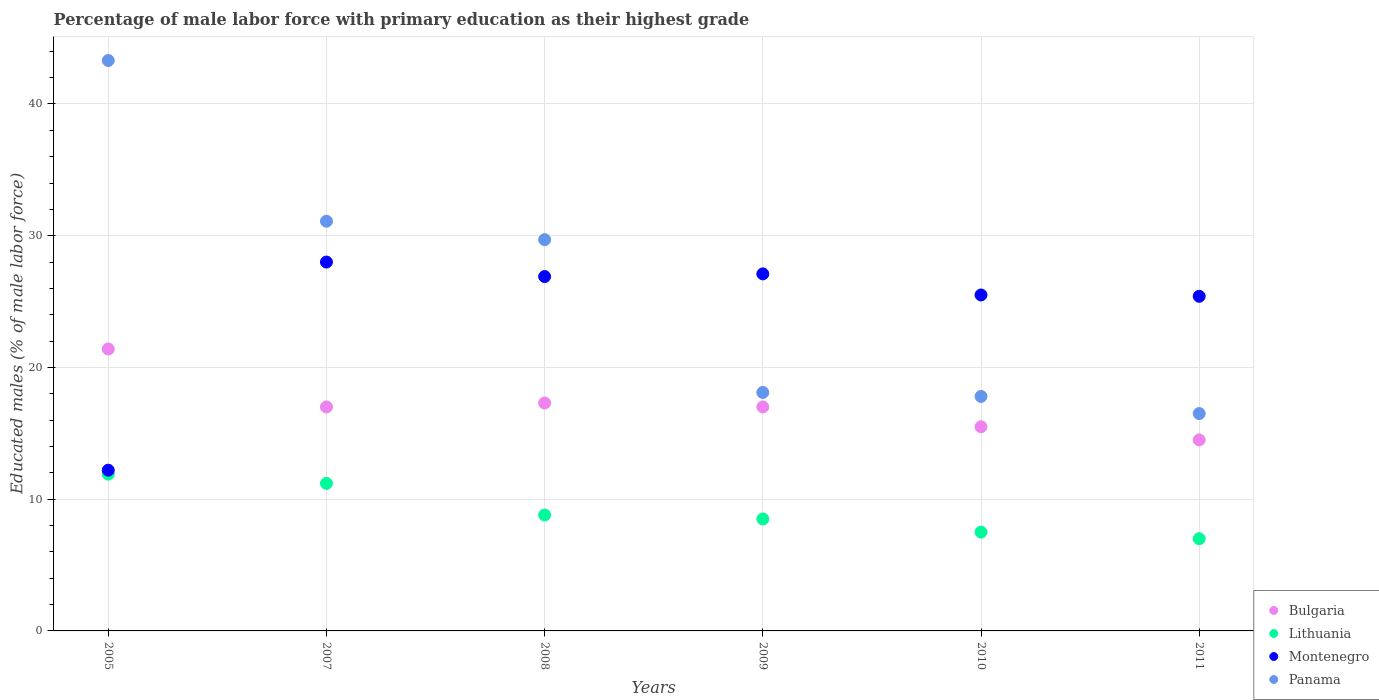Is the number of dotlines equal to the number of legend labels?
Your answer should be very brief. Yes. What is the percentage of male labor force with primary education in Montenegro in 2005?
Make the answer very short. 12.2. Across all years, what is the maximum percentage of male labor force with primary education in Lithuania?
Provide a succinct answer. 11.9. Across all years, what is the minimum percentage of male labor force with primary education in Lithuania?
Offer a terse response. 7. In which year was the percentage of male labor force with primary education in Panama maximum?
Offer a very short reply. 2005. What is the total percentage of male labor force with primary education in Bulgaria in the graph?
Keep it short and to the point. 102.7. What is the difference between the percentage of male labor force with primary education in Bulgaria in 2007 and that in 2010?
Keep it short and to the point. 1.5. What is the difference between the percentage of male labor force with primary education in Montenegro in 2005 and the percentage of male labor force with primary education in Lithuania in 2010?
Your answer should be compact. 4.7. What is the average percentage of male labor force with primary education in Bulgaria per year?
Make the answer very short. 17.12. In the year 2009, what is the difference between the percentage of male labor force with primary education in Bulgaria and percentage of male labor force with primary education in Panama?
Ensure brevity in your answer.  -1.1. What is the ratio of the percentage of male labor force with primary education in Montenegro in 2005 to that in 2011?
Provide a short and direct response. 0.48. Is the difference between the percentage of male labor force with primary education in Bulgaria in 2005 and 2008 greater than the difference between the percentage of male labor force with primary education in Panama in 2005 and 2008?
Give a very brief answer. No. What is the difference between the highest and the second highest percentage of male labor force with primary education in Panama?
Provide a short and direct response. 12.2. What is the difference between the highest and the lowest percentage of male labor force with primary education in Bulgaria?
Your response must be concise. 6.9. Is it the case that in every year, the sum of the percentage of male labor force with primary education in Montenegro and percentage of male labor force with primary education in Panama  is greater than the sum of percentage of male labor force with primary education in Bulgaria and percentage of male labor force with primary education in Lithuania?
Offer a very short reply. No. Does the percentage of male labor force with primary education in Panama monotonically increase over the years?
Your answer should be very brief. No. How many dotlines are there?
Offer a terse response. 4. How many years are there in the graph?
Your answer should be compact. 6. Are the values on the major ticks of Y-axis written in scientific E-notation?
Offer a terse response. No. Does the graph contain any zero values?
Provide a short and direct response. No. Where does the legend appear in the graph?
Your answer should be compact. Bottom right. How are the legend labels stacked?
Offer a terse response. Vertical. What is the title of the graph?
Your response must be concise. Percentage of male labor force with primary education as their highest grade. Does "Sri Lanka" appear as one of the legend labels in the graph?
Give a very brief answer. No. What is the label or title of the X-axis?
Offer a very short reply. Years. What is the label or title of the Y-axis?
Provide a short and direct response. Educated males (% of male labor force). What is the Educated males (% of male labor force) of Bulgaria in 2005?
Ensure brevity in your answer.  21.4. What is the Educated males (% of male labor force) in Lithuania in 2005?
Make the answer very short. 11.9. What is the Educated males (% of male labor force) of Montenegro in 2005?
Provide a succinct answer. 12.2. What is the Educated males (% of male labor force) in Panama in 2005?
Keep it short and to the point. 43.3. What is the Educated males (% of male labor force) in Lithuania in 2007?
Ensure brevity in your answer.  11.2. What is the Educated males (% of male labor force) of Montenegro in 2007?
Your response must be concise. 28. What is the Educated males (% of male labor force) in Panama in 2007?
Provide a short and direct response. 31.1. What is the Educated males (% of male labor force) of Bulgaria in 2008?
Ensure brevity in your answer.  17.3. What is the Educated males (% of male labor force) in Lithuania in 2008?
Provide a succinct answer. 8.8. What is the Educated males (% of male labor force) of Montenegro in 2008?
Your answer should be compact. 26.9. What is the Educated males (% of male labor force) of Panama in 2008?
Provide a succinct answer. 29.7. What is the Educated males (% of male labor force) in Lithuania in 2009?
Make the answer very short. 8.5. What is the Educated males (% of male labor force) in Montenegro in 2009?
Give a very brief answer. 27.1. What is the Educated males (% of male labor force) in Panama in 2009?
Ensure brevity in your answer.  18.1. What is the Educated males (% of male labor force) of Lithuania in 2010?
Offer a terse response. 7.5. What is the Educated males (% of male labor force) in Montenegro in 2010?
Ensure brevity in your answer.  25.5. What is the Educated males (% of male labor force) in Panama in 2010?
Your answer should be very brief. 17.8. What is the Educated males (% of male labor force) in Montenegro in 2011?
Provide a succinct answer. 25.4. Across all years, what is the maximum Educated males (% of male labor force) in Bulgaria?
Your answer should be compact. 21.4. Across all years, what is the maximum Educated males (% of male labor force) in Lithuania?
Your answer should be compact. 11.9. Across all years, what is the maximum Educated males (% of male labor force) of Panama?
Give a very brief answer. 43.3. Across all years, what is the minimum Educated males (% of male labor force) of Bulgaria?
Your answer should be compact. 14.5. Across all years, what is the minimum Educated males (% of male labor force) in Lithuania?
Offer a very short reply. 7. Across all years, what is the minimum Educated males (% of male labor force) of Montenegro?
Ensure brevity in your answer.  12.2. Across all years, what is the minimum Educated males (% of male labor force) of Panama?
Ensure brevity in your answer.  16.5. What is the total Educated males (% of male labor force) of Bulgaria in the graph?
Offer a very short reply. 102.7. What is the total Educated males (% of male labor force) of Lithuania in the graph?
Ensure brevity in your answer.  54.9. What is the total Educated males (% of male labor force) of Montenegro in the graph?
Your answer should be compact. 145.1. What is the total Educated males (% of male labor force) of Panama in the graph?
Provide a short and direct response. 156.5. What is the difference between the Educated males (% of male labor force) in Lithuania in 2005 and that in 2007?
Your answer should be compact. 0.7. What is the difference between the Educated males (% of male labor force) in Montenegro in 2005 and that in 2007?
Your answer should be compact. -15.8. What is the difference between the Educated males (% of male labor force) in Bulgaria in 2005 and that in 2008?
Keep it short and to the point. 4.1. What is the difference between the Educated males (% of male labor force) of Lithuania in 2005 and that in 2008?
Keep it short and to the point. 3.1. What is the difference between the Educated males (% of male labor force) in Montenegro in 2005 and that in 2008?
Make the answer very short. -14.7. What is the difference between the Educated males (% of male labor force) of Montenegro in 2005 and that in 2009?
Your answer should be very brief. -14.9. What is the difference between the Educated males (% of male labor force) of Panama in 2005 and that in 2009?
Offer a terse response. 25.2. What is the difference between the Educated males (% of male labor force) of Bulgaria in 2005 and that in 2010?
Provide a succinct answer. 5.9. What is the difference between the Educated males (% of male labor force) of Lithuania in 2005 and that in 2010?
Make the answer very short. 4.4. What is the difference between the Educated males (% of male labor force) in Panama in 2005 and that in 2010?
Ensure brevity in your answer.  25.5. What is the difference between the Educated males (% of male labor force) in Montenegro in 2005 and that in 2011?
Offer a terse response. -13.2. What is the difference between the Educated males (% of male labor force) of Panama in 2005 and that in 2011?
Your answer should be very brief. 26.8. What is the difference between the Educated males (% of male labor force) of Lithuania in 2007 and that in 2008?
Your answer should be very brief. 2.4. What is the difference between the Educated males (% of male labor force) in Montenegro in 2007 and that in 2008?
Your answer should be very brief. 1.1. What is the difference between the Educated males (% of male labor force) in Lithuania in 2007 and that in 2010?
Provide a succinct answer. 3.7. What is the difference between the Educated males (% of male labor force) in Montenegro in 2007 and that in 2010?
Offer a terse response. 2.5. What is the difference between the Educated males (% of male labor force) of Panama in 2007 and that in 2010?
Keep it short and to the point. 13.3. What is the difference between the Educated males (% of male labor force) in Bulgaria in 2008 and that in 2009?
Ensure brevity in your answer.  0.3. What is the difference between the Educated males (% of male labor force) in Montenegro in 2008 and that in 2009?
Your response must be concise. -0.2. What is the difference between the Educated males (% of male labor force) of Panama in 2008 and that in 2009?
Your answer should be very brief. 11.6. What is the difference between the Educated males (% of male labor force) in Bulgaria in 2008 and that in 2010?
Provide a succinct answer. 1.8. What is the difference between the Educated males (% of male labor force) in Panama in 2008 and that in 2010?
Your response must be concise. 11.9. What is the difference between the Educated males (% of male labor force) of Bulgaria in 2008 and that in 2011?
Give a very brief answer. 2.8. What is the difference between the Educated males (% of male labor force) in Montenegro in 2008 and that in 2011?
Provide a succinct answer. 1.5. What is the difference between the Educated males (% of male labor force) of Lithuania in 2009 and that in 2011?
Make the answer very short. 1.5. What is the difference between the Educated males (% of male labor force) of Panama in 2009 and that in 2011?
Give a very brief answer. 1.6. What is the difference between the Educated males (% of male labor force) of Lithuania in 2010 and that in 2011?
Your response must be concise. 0.5. What is the difference between the Educated males (% of male labor force) in Panama in 2010 and that in 2011?
Your answer should be compact. 1.3. What is the difference between the Educated males (% of male labor force) in Bulgaria in 2005 and the Educated males (% of male labor force) in Montenegro in 2007?
Provide a short and direct response. -6.6. What is the difference between the Educated males (% of male labor force) in Lithuania in 2005 and the Educated males (% of male labor force) in Montenegro in 2007?
Provide a short and direct response. -16.1. What is the difference between the Educated males (% of male labor force) of Lithuania in 2005 and the Educated males (% of male labor force) of Panama in 2007?
Provide a succinct answer. -19.2. What is the difference between the Educated males (% of male labor force) in Montenegro in 2005 and the Educated males (% of male labor force) in Panama in 2007?
Give a very brief answer. -18.9. What is the difference between the Educated males (% of male labor force) of Bulgaria in 2005 and the Educated males (% of male labor force) of Lithuania in 2008?
Offer a very short reply. 12.6. What is the difference between the Educated males (% of male labor force) in Bulgaria in 2005 and the Educated males (% of male labor force) in Panama in 2008?
Provide a succinct answer. -8.3. What is the difference between the Educated males (% of male labor force) in Lithuania in 2005 and the Educated males (% of male labor force) in Panama in 2008?
Your response must be concise. -17.8. What is the difference between the Educated males (% of male labor force) in Montenegro in 2005 and the Educated males (% of male labor force) in Panama in 2008?
Ensure brevity in your answer.  -17.5. What is the difference between the Educated males (% of male labor force) in Bulgaria in 2005 and the Educated males (% of male labor force) in Panama in 2009?
Offer a terse response. 3.3. What is the difference between the Educated males (% of male labor force) of Lithuania in 2005 and the Educated males (% of male labor force) of Montenegro in 2009?
Keep it short and to the point. -15.2. What is the difference between the Educated males (% of male labor force) in Lithuania in 2005 and the Educated males (% of male labor force) in Panama in 2009?
Provide a succinct answer. -6.2. What is the difference between the Educated males (% of male labor force) of Lithuania in 2005 and the Educated males (% of male labor force) of Montenegro in 2010?
Your response must be concise. -13.6. What is the difference between the Educated males (% of male labor force) in Lithuania in 2005 and the Educated males (% of male labor force) in Panama in 2010?
Provide a short and direct response. -5.9. What is the difference between the Educated males (% of male labor force) of Bulgaria in 2005 and the Educated males (% of male labor force) of Lithuania in 2011?
Provide a short and direct response. 14.4. What is the difference between the Educated males (% of male labor force) of Bulgaria in 2005 and the Educated males (% of male labor force) of Montenegro in 2011?
Keep it short and to the point. -4. What is the difference between the Educated males (% of male labor force) in Bulgaria in 2005 and the Educated males (% of male labor force) in Panama in 2011?
Offer a terse response. 4.9. What is the difference between the Educated males (% of male labor force) in Lithuania in 2005 and the Educated males (% of male labor force) in Montenegro in 2011?
Your answer should be very brief. -13.5. What is the difference between the Educated males (% of male labor force) of Bulgaria in 2007 and the Educated males (% of male labor force) of Panama in 2008?
Offer a terse response. -12.7. What is the difference between the Educated males (% of male labor force) of Lithuania in 2007 and the Educated males (% of male labor force) of Montenegro in 2008?
Give a very brief answer. -15.7. What is the difference between the Educated males (% of male labor force) of Lithuania in 2007 and the Educated males (% of male labor force) of Panama in 2008?
Provide a succinct answer. -18.5. What is the difference between the Educated males (% of male labor force) of Montenegro in 2007 and the Educated males (% of male labor force) of Panama in 2008?
Ensure brevity in your answer.  -1.7. What is the difference between the Educated males (% of male labor force) in Bulgaria in 2007 and the Educated males (% of male labor force) in Lithuania in 2009?
Keep it short and to the point. 8.5. What is the difference between the Educated males (% of male labor force) of Bulgaria in 2007 and the Educated males (% of male labor force) of Panama in 2009?
Provide a short and direct response. -1.1. What is the difference between the Educated males (% of male labor force) in Lithuania in 2007 and the Educated males (% of male labor force) in Montenegro in 2009?
Give a very brief answer. -15.9. What is the difference between the Educated males (% of male labor force) in Lithuania in 2007 and the Educated males (% of male labor force) in Panama in 2009?
Keep it short and to the point. -6.9. What is the difference between the Educated males (% of male labor force) in Bulgaria in 2007 and the Educated males (% of male labor force) in Lithuania in 2010?
Give a very brief answer. 9.5. What is the difference between the Educated males (% of male labor force) in Bulgaria in 2007 and the Educated males (% of male labor force) in Montenegro in 2010?
Your answer should be very brief. -8.5. What is the difference between the Educated males (% of male labor force) of Bulgaria in 2007 and the Educated males (% of male labor force) of Panama in 2010?
Your response must be concise. -0.8. What is the difference between the Educated males (% of male labor force) of Lithuania in 2007 and the Educated males (% of male labor force) of Montenegro in 2010?
Your response must be concise. -14.3. What is the difference between the Educated males (% of male labor force) in Bulgaria in 2007 and the Educated males (% of male labor force) in Lithuania in 2011?
Your answer should be very brief. 10. What is the difference between the Educated males (% of male labor force) of Bulgaria in 2007 and the Educated males (% of male labor force) of Montenegro in 2011?
Give a very brief answer. -8.4. What is the difference between the Educated males (% of male labor force) of Bulgaria in 2007 and the Educated males (% of male labor force) of Panama in 2011?
Offer a very short reply. 0.5. What is the difference between the Educated males (% of male labor force) of Lithuania in 2007 and the Educated males (% of male labor force) of Panama in 2011?
Make the answer very short. -5.3. What is the difference between the Educated males (% of male labor force) of Bulgaria in 2008 and the Educated males (% of male labor force) of Lithuania in 2009?
Make the answer very short. 8.8. What is the difference between the Educated males (% of male labor force) in Bulgaria in 2008 and the Educated males (% of male labor force) in Panama in 2009?
Make the answer very short. -0.8. What is the difference between the Educated males (% of male labor force) of Lithuania in 2008 and the Educated males (% of male labor force) of Montenegro in 2009?
Offer a terse response. -18.3. What is the difference between the Educated males (% of male labor force) in Montenegro in 2008 and the Educated males (% of male labor force) in Panama in 2009?
Offer a terse response. 8.8. What is the difference between the Educated males (% of male labor force) of Bulgaria in 2008 and the Educated males (% of male labor force) of Montenegro in 2010?
Keep it short and to the point. -8.2. What is the difference between the Educated males (% of male labor force) in Bulgaria in 2008 and the Educated males (% of male labor force) in Panama in 2010?
Your answer should be compact. -0.5. What is the difference between the Educated males (% of male labor force) in Lithuania in 2008 and the Educated males (% of male labor force) in Montenegro in 2010?
Offer a very short reply. -16.7. What is the difference between the Educated males (% of male labor force) of Bulgaria in 2008 and the Educated males (% of male labor force) of Panama in 2011?
Keep it short and to the point. 0.8. What is the difference between the Educated males (% of male labor force) of Lithuania in 2008 and the Educated males (% of male labor force) of Montenegro in 2011?
Your response must be concise. -16.6. What is the difference between the Educated males (% of male labor force) of Montenegro in 2008 and the Educated males (% of male labor force) of Panama in 2011?
Keep it short and to the point. 10.4. What is the difference between the Educated males (% of male labor force) of Bulgaria in 2009 and the Educated males (% of male labor force) of Lithuania in 2010?
Provide a short and direct response. 9.5. What is the difference between the Educated males (% of male labor force) in Bulgaria in 2009 and the Educated males (% of male labor force) in Montenegro in 2010?
Make the answer very short. -8.5. What is the difference between the Educated males (% of male labor force) of Bulgaria in 2009 and the Educated males (% of male labor force) of Panama in 2010?
Your response must be concise. -0.8. What is the difference between the Educated males (% of male labor force) in Lithuania in 2009 and the Educated males (% of male labor force) in Montenegro in 2010?
Give a very brief answer. -17. What is the difference between the Educated males (% of male labor force) of Lithuania in 2009 and the Educated males (% of male labor force) of Panama in 2010?
Keep it short and to the point. -9.3. What is the difference between the Educated males (% of male labor force) of Lithuania in 2009 and the Educated males (% of male labor force) of Montenegro in 2011?
Give a very brief answer. -16.9. What is the difference between the Educated males (% of male labor force) of Bulgaria in 2010 and the Educated males (% of male labor force) of Lithuania in 2011?
Keep it short and to the point. 8.5. What is the difference between the Educated males (% of male labor force) in Lithuania in 2010 and the Educated males (% of male labor force) in Montenegro in 2011?
Provide a short and direct response. -17.9. What is the average Educated males (% of male labor force) in Bulgaria per year?
Your answer should be compact. 17.12. What is the average Educated males (% of male labor force) in Lithuania per year?
Provide a succinct answer. 9.15. What is the average Educated males (% of male labor force) in Montenegro per year?
Keep it short and to the point. 24.18. What is the average Educated males (% of male labor force) in Panama per year?
Your response must be concise. 26.08. In the year 2005, what is the difference between the Educated males (% of male labor force) in Bulgaria and Educated males (% of male labor force) in Lithuania?
Give a very brief answer. 9.5. In the year 2005, what is the difference between the Educated males (% of male labor force) in Bulgaria and Educated males (% of male labor force) in Montenegro?
Your answer should be compact. 9.2. In the year 2005, what is the difference between the Educated males (% of male labor force) in Bulgaria and Educated males (% of male labor force) in Panama?
Offer a very short reply. -21.9. In the year 2005, what is the difference between the Educated males (% of male labor force) in Lithuania and Educated males (% of male labor force) in Panama?
Ensure brevity in your answer.  -31.4. In the year 2005, what is the difference between the Educated males (% of male labor force) of Montenegro and Educated males (% of male labor force) of Panama?
Offer a terse response. -31.1. In the year 2007, what is the difference between the Educated males (% of male labor force) in Bulgaria and Educated males (% of male labor force) in Lithuania?
Offer a terse response. 5.8. In the year 2007, what is the difference between the Educated males (% of male labor force) of Bulgaria and Educated males (% of male labor force) of Panama?
Make the answer very short. -14.1. In the year 2007, what is the difference between the Educated males (% of male labor force) in Lithuania and Educated males (% of male labor force) in Montenegro?
Give a very brief answer. -16.8. In the year 2007, what is the difference between the Educated males (% of male labor force) in Lithuania and Educated males (% of male labor force) in Panama?
Give a very brief answer. -19.9. In the year 2007, what is the difference between the Educated males (% of male labor force) of Montenegro and Educated males (% of male labor force) of Panama?
Make the answer very short. -3.1. In the year 2008, what is the difference between the Educated males (% of male labor force) in Bulgaria and Educated males (% of male labor force) in Lithuania?
Keep it short and to the point. 8.5. In the year 2008, what is the difference between the Educated males (% of male labor force) of Bulgaria and Educated males (% of male labor force) of Montenegro?
Give a very brief answer. -9.6. In the year 2008, what is the difference between the Educated males (% of male labor force) of Bulgaria and Educated males (% of male labor force) of Panama?
Offer a terse response. -12.4. In the year 2008, what is the difference between the Educated males (% of male labor force) in Lithuania and Educated males (% of male labor force) in Montenegro?
Provide a succinct answer. -18.1. In the year 2008, what is the difference between the Educated males (% of male labor force) in Lithuania and Educated males (% of male labor force) in Panama?
Your answer should be compact. -20.9. In the year 2008, what is the difference between the Educated males (% of male labor force) of Montenegro and Educated males (% of male labor force) of Panama?
Offer a terse response. -2.8. In the year 2009, what is the difference between the Educated males (% of male labor force) in Bulgaria and Educated males (% of male labor force) in Lithuania?
Ensure brevity in your answer.  8.5. In the year 2009, what is the difference between the Educated males (% of male labor force) in Lithuania and Educated males (% of male labor force) in Montenegro?
Ensure brevity in your answer.  -18.6. In the year 2010, what is the difference between the Educated males (% of male labor force) of Bulgaria and Educated males (% of male labor force) of Montenegro?
Provide a succinct answer. -10. In the year 2011, what is the difference between the Educated males (% of male labor force) in Bulgaria and Educated males (% of male labor force) in Lithuania?
Give a very brief answer. 7.5. In the year 2011, what is the difference between the Educated males (% of male labor force) in Bulgaria and Educated males (% of male labor force) in Montenegro?
Ensure brevity in your answer.  -10.9. In the year 2011, what is the difference between the Educated males (% of male labor force) in Bulgaria and Educated males (% of male labor force) in Panama?
Provide a short and direct response. -2. In the year 2011, what is the difference between the Educated males (% of male labor force) in Lithuania and Educated males (% of male labor force) in Montenegro?
Your answer should be compact. -18.4. What is the ratio of the Educated males (% of male labor force) in Bulgaria in 2005 to that in 2007?
Ensure brevity in your answer.  1.26. What is the ratio of the Educated males (% of male labor force) in Lithuania in 2005 to that in 2007?
Your answer should be very brief. 1.06. What is the ratio of the Educated males (% of male labor force) of Montenegro in 2005 to that in 2007?
Provide a succinct answer. 0.44. What is the ratio of the Educated males (% of male labor force) of Panama in 2005 to that in 2007?
Keep it short and to the point. 1.39. What is the ratio of the Educated males (% of male labor force) in Bulgaria in 2005 to that in 2008?
Provide a short and direct response. 1.24. What is the ratio of the Educated males (% of male labor force) in Lithuania in 2005 to that in 2008?
Make the answer very short. 1.35. What is the ratio of the Educated males (% of male labor force) in Montenegro in 2005 to that in 2008?
Give a very brief answer. 0.45. What is the ratio of the Educated males (% of male labor force) in Panama in 2005 to that in 2008?
Give a very brief answer. 1.46. What is the ratio of the Educated males (% of male labor force) in Bulgaria in 2005 to that in 2009?
Ensure brevity in your answer.  1.26. What is the ratio of the Educated males (% of male labor force) of Lithuania in 2005 to that in 2009?
Your answer should be very brief. 1.4. What is the ratio of the Educated males (% of male labor force) in Montenegro in 2005 to that in 2009?
Your answer should be very brief. 0.45. What is the ratio of the Educated males (% of male labor force) in Panama in 2005 to that in 2009?
Give a very brief answer. 2.39. What is the ratio of the Educated males (% of male labor force) in Bulgaria in 2005 to that in 2010?
Your answer should be compact. 1.38. What is the ratio of the Educated males (% of male labor force) in Lithuania in 2005 to that in 2010?
Provide a short and direct response. 1.59. What is the ratio of the Educated males (% of male labor force) in Montenegro in 2005 to that in 2010?
Your answer should be compact. 0.48. What is the ratio of the Educated males (% of male labor force) in Panama in 2005 to that in 2010?
Offer a very short reply. 2.43. What is the ratio of the Educated males (% of male labor force) of Bulgaria in 2005 to that in 2011?
Offer a terse response. 1.48. What is the ratio of the Educated males (% of male labor force) of Montenegro in 2005 to that in 2011?
Make the answer very short. 0.48. What is the ratio of the Educated males (% of male labor force) in Panama in 2005 to that in 2011?
Ensure brevity in your answer.  2.62. What is the ratio of the Educated males (% of male labor force) in Bulgaria in 2007 to that in 2008?
Make the answer very short. 0.98. What is the ratio of the Educated males (% of male labor force) in Lithuania in 2007 to that in 2008?
Offer a terse response. 1.27. What is the ratio of the Educated males (% of male labor force) of Montenegro in 2007 to that in 2008?
Your response must be concise. 1.04. What is the ratio of the Educated males (% of male labor force) of Panama in 2007 to that in 2008?
Provide a succinct answer. 1.05. What is the ratio of the Educated males (% of male labor force) in Lithuania in 2007 to that in 2009?
Your answer should be very brief. 1.32. What is the ratio of the Educated males (% of male labor force) in Montenegro in 2007 to that in 2009?
Offer a terse response. 1.03. What is the ratio of the Educated males (% of male labor force) in Panama in 2007 to that in 2009?
Keep it short and to the point. 1.72. What is the ratio of the Educated males (% of male labor force) of Bulgaria in 2007 to that in 2010?
Provide a short and direct response. 1.1. What is the ratio of the Educated males (% of male labor force) of Lithuania in 2007 to that in 2010?
Provide a short and direct response. 1.49. What is the ratio of the Educated males (% of male labor force) of Montenegro in 2007 to that in 2010?
Provide a short and direct response. 1.1. What is the ratio of the Educated males (% of male labor force) of Panama in 2007 to that in 2010?
Give a very brief answer. 1.75. What is the ratio of the Educated males (% of male labor force) of Bulgaria in 2007 to that in 2011?
Offer a very short reply. 1.17. What is the ratio of the Educated males (% of male labor force) of Lithuania in 2007 to that in 2011?
Make the answer very short. 1.6. What is the ratio of the Educated males (% of male labor force) of Montenegro in 2007 to that in 2011?
Ensure brevity in your answer.  1.1. What is the ratio of the Educated males (% of male labor force) in Panama in 2007 to that in 2011?
Make the answer very short. 1.88. What is the ratio of the Educated males (% of male labor force) in Bulgaria in 2008 to that in 2009?
Keep it short and to the point. 1.02. What is the ratio of the Educated males (% of male labor force) of Lithuania in 2008 to that in 2009?
Your response must be concise. 1.04. What is the ratio of the Educated males (% of male labor force) in Panama in 2008 to that in 2009?
Your answer should be compact. 1.64. What is the ratio of the Educated males (% of male labor force) in Bulgaria in 2008 to that in 2010?
Provide a succinct answer. 1.12. What is the ratio of the Educated males (% of male labor force) in Lithuania in 2008 to that in 2010?
Give a very brief answer. 1.17. What is the ratio of the Educated males (% of male labor force) of Montenegro in 2008 to that in 2010?
Offer a terse response. 1.05. What is the ratio of the Educated males (% of male labor force) of Panama in 2008 to that in 2010?
Your response must be concise. 1.67. What is the ratio of the Educated males (% of male labor force) of Bulgaria in 2008 to that in 2011?
Ensure brevity in your answer.  1.19. What is the ratio of the Educated males (% of male labor force) in Lithuania in 2008 to that in 2011?
Your answer should be compact. 1.26. What is the ratio of the Educated males (% of male labor force) of Montenegro in 2008 to that in 2011?
Give a very brief answer. 1.06. What is the ratio of the Educated males (% of male labor force) of Bulgaria in 2009 to that in 2010?
Keep it short and to the point. 1.1. What is the ratio of the Educated males (% of male labor force) of Lithuania in 2009 to that in 2010?
Your answer should be very brief. 1.13. What is the ratio of the Educated males (% of male labor force) of Montenegro in 2009 to that in 2010?
Provide a short and direct response. 1.06. What is the ratio of the Educated males (% of male labor force) of Panama in 2009 to that in 2010?
Your response must be concise. 1.02. What is the ratio of the Educated males (% of male labor force) in Bulgaria in 2009 to that in 2011?
Provide a succinct answer. 1.17. What is the ratio of the Educated males (% of male labor force) in Lithuania in 2009 to that in 2011?
Your answer should be very brief. 1.21. What is the ratio of the Educated males (% of male labor force) of Montenegro in 2009 to that in 2011?
Keep it short and to the point. 1.07. What is the ratio of the Educated males (% of male labor force) in Panama in 2009 to that in 2011?
Your response must be concise. 1.1. What is the ratio of the Educated males (% of male labor force) of Bulgaria in 2010 to that in 2011?
Offer a terse response. 1.07. What is the ratio of the Educated males (% of male labor force) of Lithuania in 2010 to that in 2011?
Offer a very short reply. 1.07. What is the ratio of the Educated males (% of male labor force) in Panama in 2010 to that in 2011?
Provide a short and direct response. 1.08. What is the difference between the highest and the second highest Educated males (% of male labor force) in Bulgaria?
Ensure brevity in your answer.  4.1. What is the difference between the highest and the second highest Educated males (% of male labor force) of Lithuania?
Offer a very short reply. 0.7. What is the difference between the highest and the second highest Educated males (% of male labor force) in Panama?
Give a very brief answer. 12.2. What is the difference between the highest and the lowest Educated males (% of male labor force) in Bulgaria?
Your answer should be very brief. 6.9. What is the difference between the highest and the lowest Educated males (% of male labor force) in Montenegro?
Provide a short and direct response. 15.8. What is the difference between the highest and the lowest Educated males (% of male labor force) in Panama?
Your response must be concise. 26.8. 